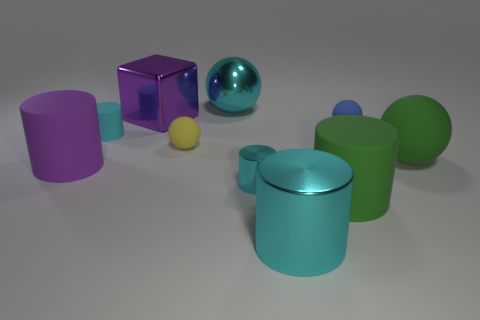Subtract all cyan cylinders. How many were subtracted if there are1cyan cylinders left? 2 Subtract all brown cubes. How many cyan cylinders are left? 3 Subtract all large cyan metallic balls. How many balls are left? 3 Subtract all green balls. How many balls are left? 3 Subtract all brown cylinders. Subtract all cyan blocks. How many cylinders are left? 5 Subtract all spheres. How many objects are left? 6 Subtract 1 yellow balls. How many objects are left? 9 Subtract all big brown objects. Subtract all small matte balls. How many objects are left? 8 Add 8 blocks. How many blocks are left? 9 Add 8 purple rubber cubes. How many purple rubber cubes exist? 8 